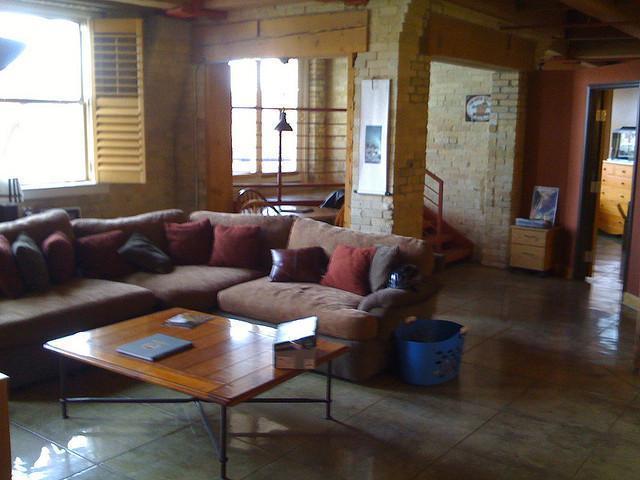How many people are in the room?
Give a very brief answer. 0. 